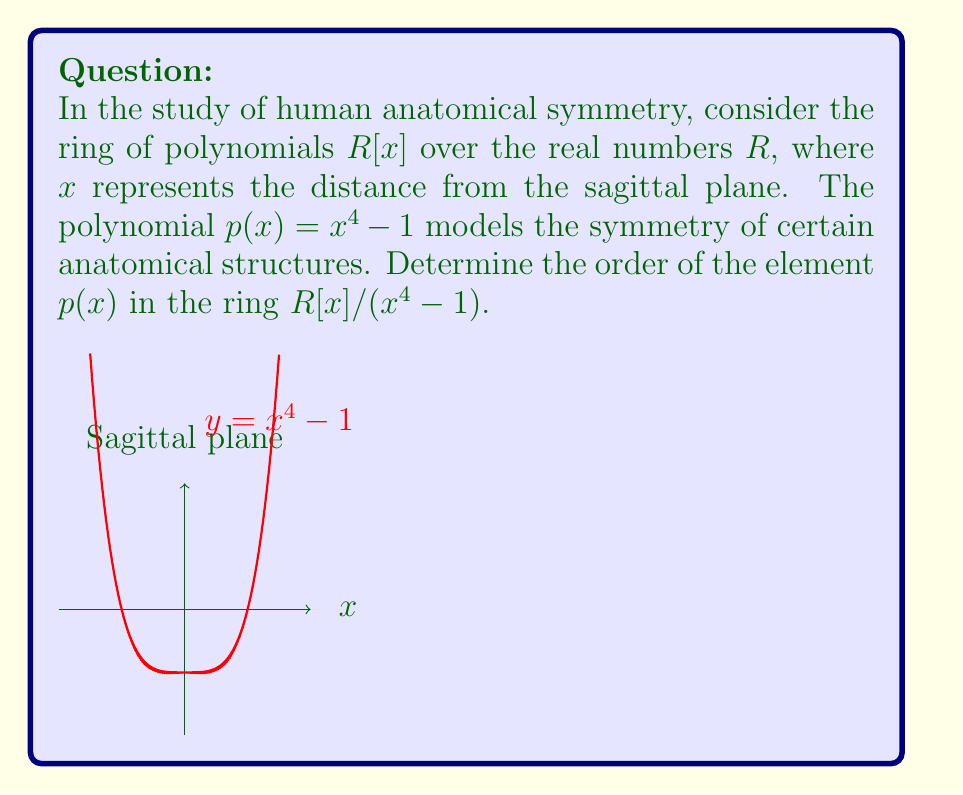Can you solve this math problem? Let's approach this step-by-step:

1) In a ring of polynomials modulo $x^4-1$, we need to find the smallest positive integer $n$ such that $(p(x))^n \equiv 1 \pmod{x^4-1}$.

2) In this case, $p(x) = x^4 - 1$, which is the same as the modulus.

3) Therefore, in $R[x]/(x^4-1)$, we have:

   $p(x) \equiv 0 \pmod{x^4-1}$

4) This means that $p(x)$ is a zero divisor in the ring $R[x]/(x^4-1)$.

5) For any zero divisor $a$ in a ring, $a^n = 0$ for some positive integer $n$.

6) In this case, $(p(x))^1 \equiv 0 \pmod{x^4-1}$

7) However, the order of an element is defined as the smallest positive integer $n$ such that $a^n = 1$, not 0.

8) Since $p(x)$ is a zero divisor, there is no positive integer $n$ for which $(p(x))^n \equiv 1 \pmod{x^4-1}$.

9) In ring theory, when an element has no finite order, we say its order is infinite.

Therefore, the order of $p(x)$ in $R[x]/(x^4-1)$ is infinite.
Answer: $\infty$ 